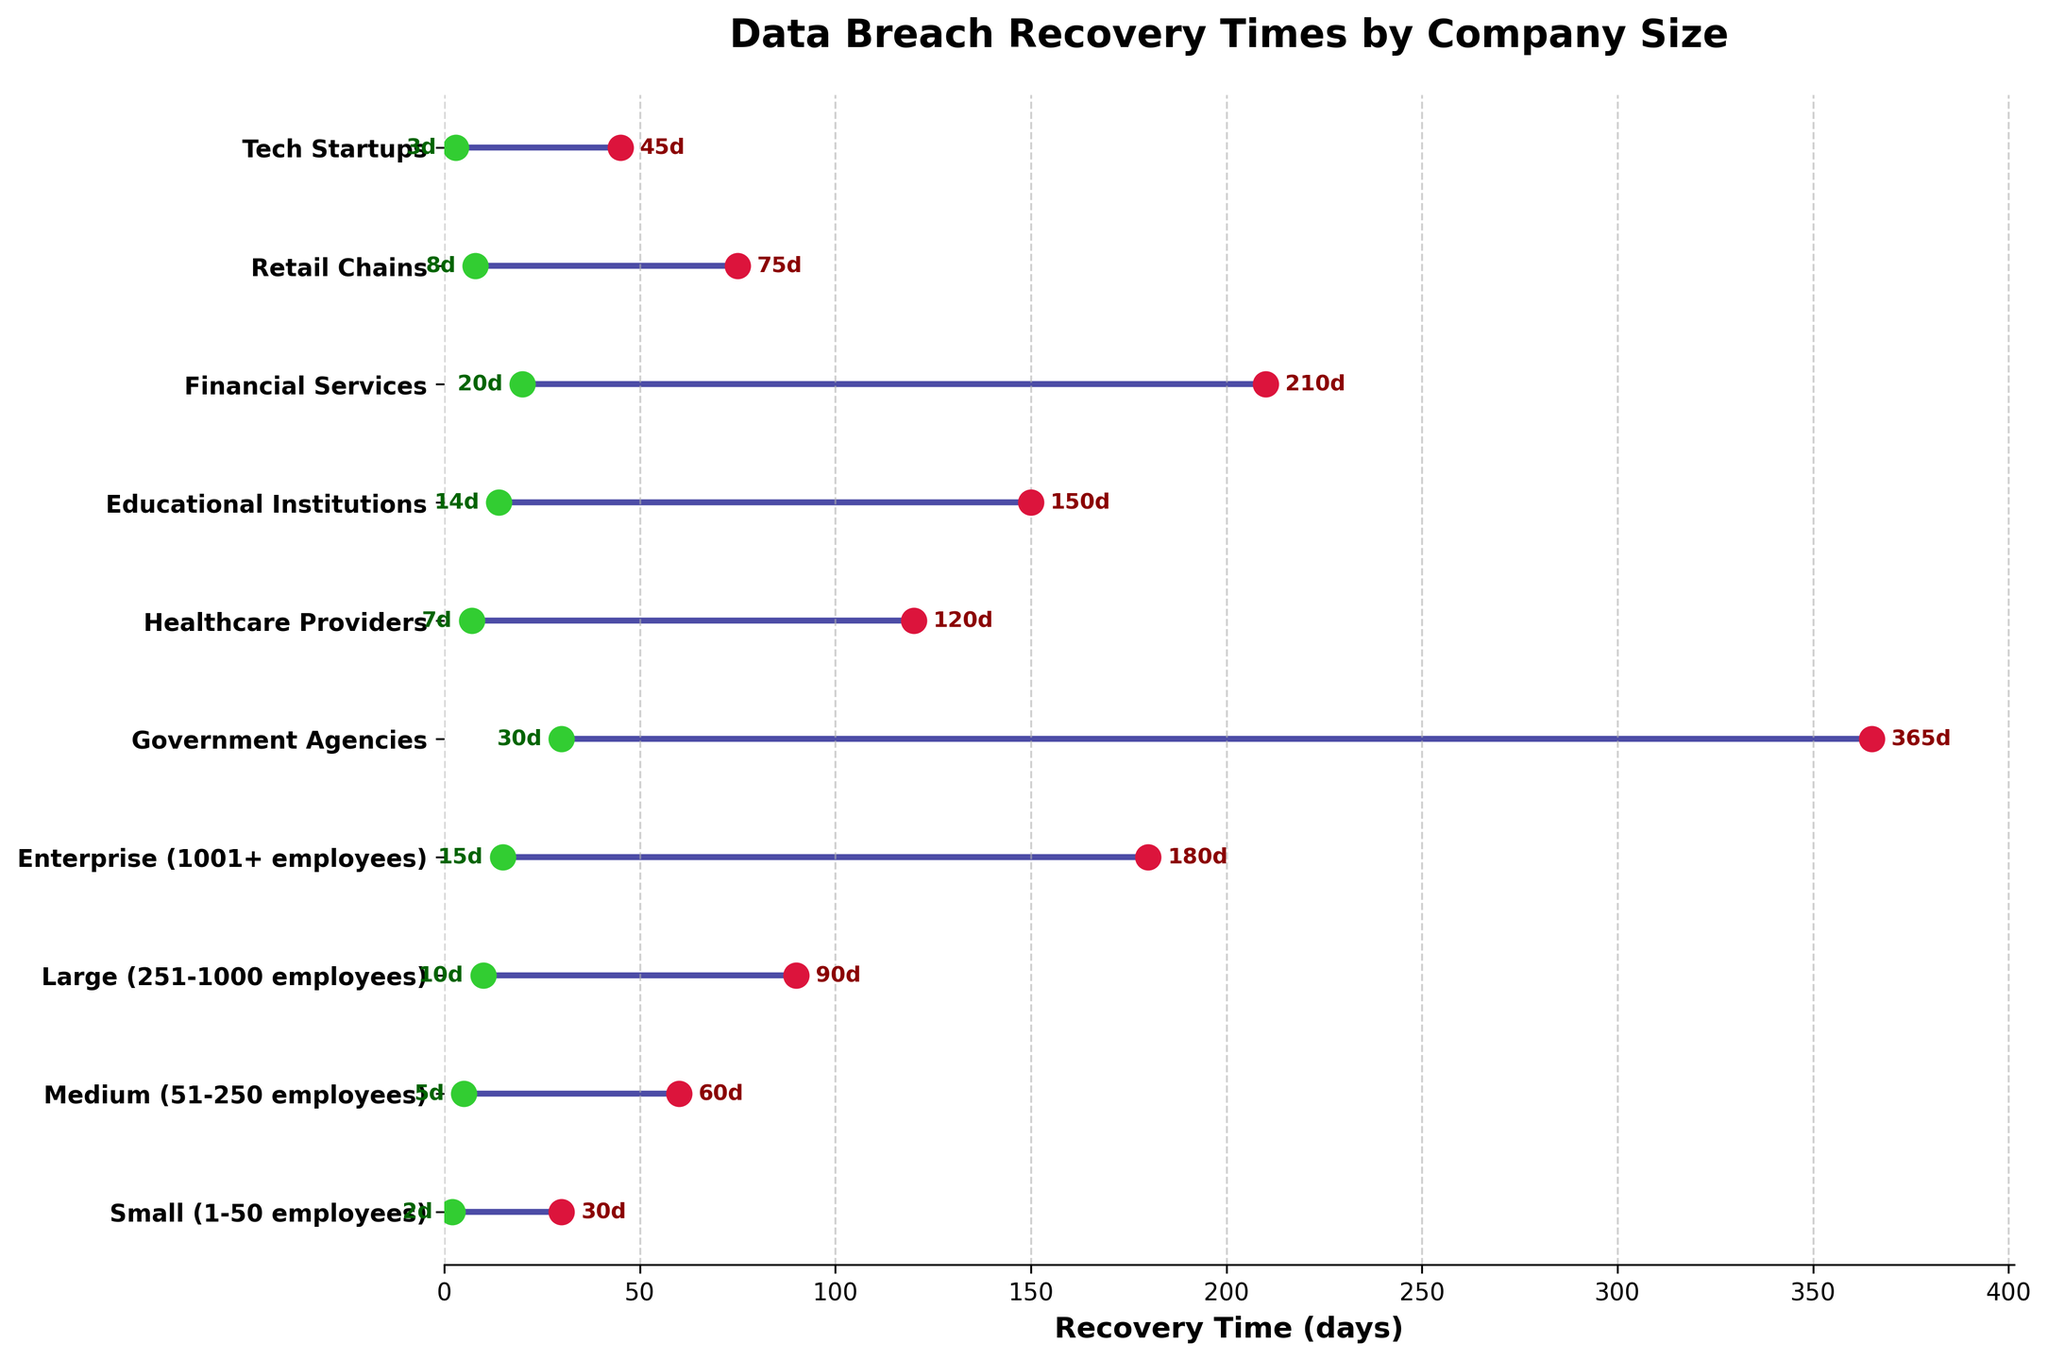which company size has the fastest recovery time? The fastest recovery time can be identified from the scatter plot. The company size with the fastest recovery time is the one with the smallest value on the x-axis for the green dot.
Answer: Tech Startups what is the range of recovery times for government agencies? The range of recovery times for government agencies can be determined by looking at where the green and red dots are placed on the x-axis for Government Agencies. The range extends from the Fastest (30 days) to the Slowest (365 days).
Answer: 30 to 365 days which two company sizes have the closest fastest recovery times? To find which two company sizes have the closest fastest recovery times, we look at the green dots and compare their x-axis values for each company size. The smallest difference in days identifies the closest fastest recovery times. In this case, Medium and Healthcare Providers both have close values of 5 and 7 days, respectively.
Answer: Medium and Healthcare Providers which industry has the largest gap between fastest and slowest recovery times? The largest gap can be found by looking at the length of the line connecting the green and red dots for each industry. The longest line identifies the industry with the largest gap. In this case, it's Financial Services, with a gap of 190 days (210 - 20).
Answer: Financial Services what is the median fastest recovery time across all groups? First, list all fastest recovery times: 2, 3, 5, 7, 8, 10, 14, 15, 20, 30. Since there are 10 data points, the median is the average of the 5th and 6th values when sorted. These values are 8 and 10. So, the median is (8 + 10) / 2 = 9.
Answer: 9 days which company size has the slowest recovery time? The slowest recovery time can be identified by the x-axis value of the red dots. The company size with the highest value on the x-axis for the red dot indicates the slowest recovery time. For this plot, it's Government Agencies with 365 days.
Answer: Government Agencies how does the recovery time of educational institutions compare to healthcare providers? To compare, we look at the recovery times of Educational Institutions and Healthcare Providers. Educational Institutions have a range of 14 to 150 days, whereas Healthcare Providers have a range of 7 to 120 days. Hence, both fastest and slowest recovery times for Educational Institutions are higher than those for Healthcare Providers.
Answer: Educational Institutions have both faster and slower recovery times higher than those of Healthcare Providers what is the total range of recovery times shown in the plot? The total range of recovery times can be found by identifying the minimum and maximum values of all plotted recovery times. The smallest value is 2 days (Small) and the largest is 365 days (Government Agencies), so the total range is 365 - 2.
Answer: 363 days 